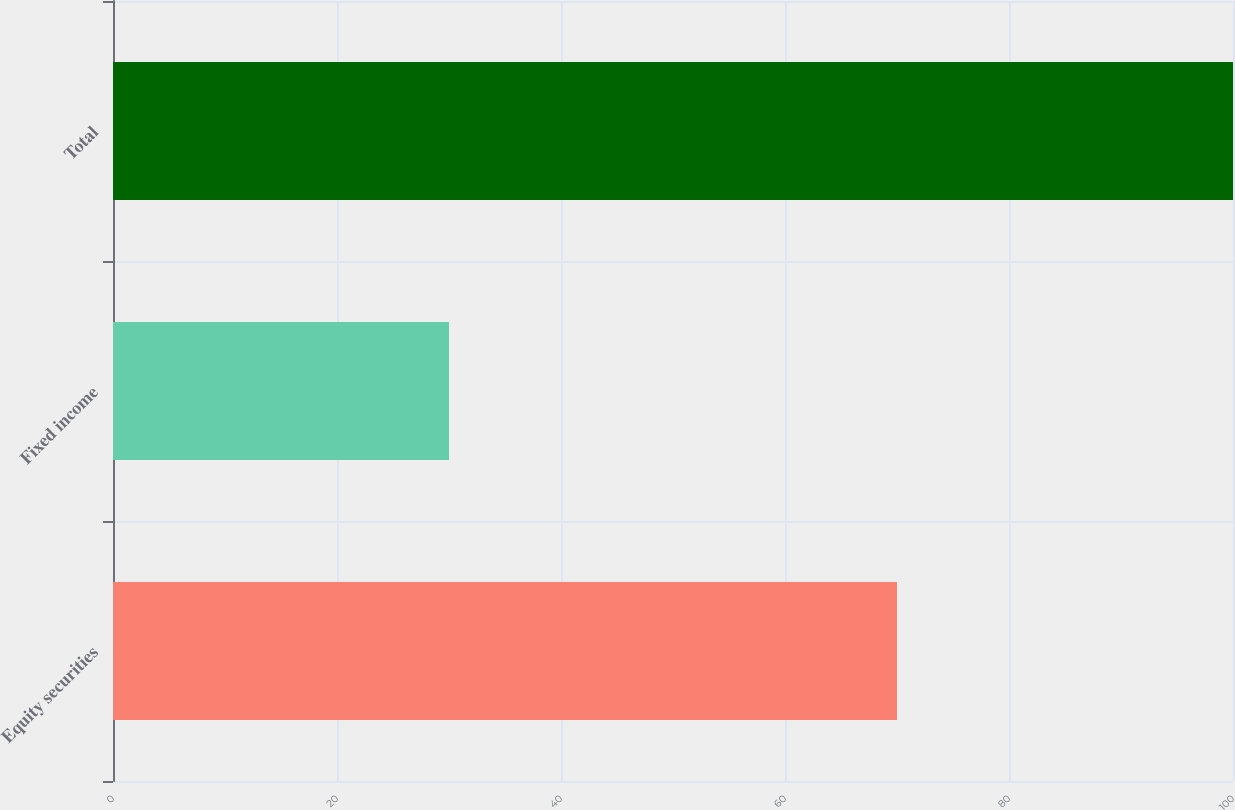Convert chart. <chart><loc_0><loc_0><loc_500><loc_500><bar_chart><fcel>Equity securities<fcel>Fixed income<fcel>Total<nl><fcel>70<fcel>30<fcel>100<nl></chart> 